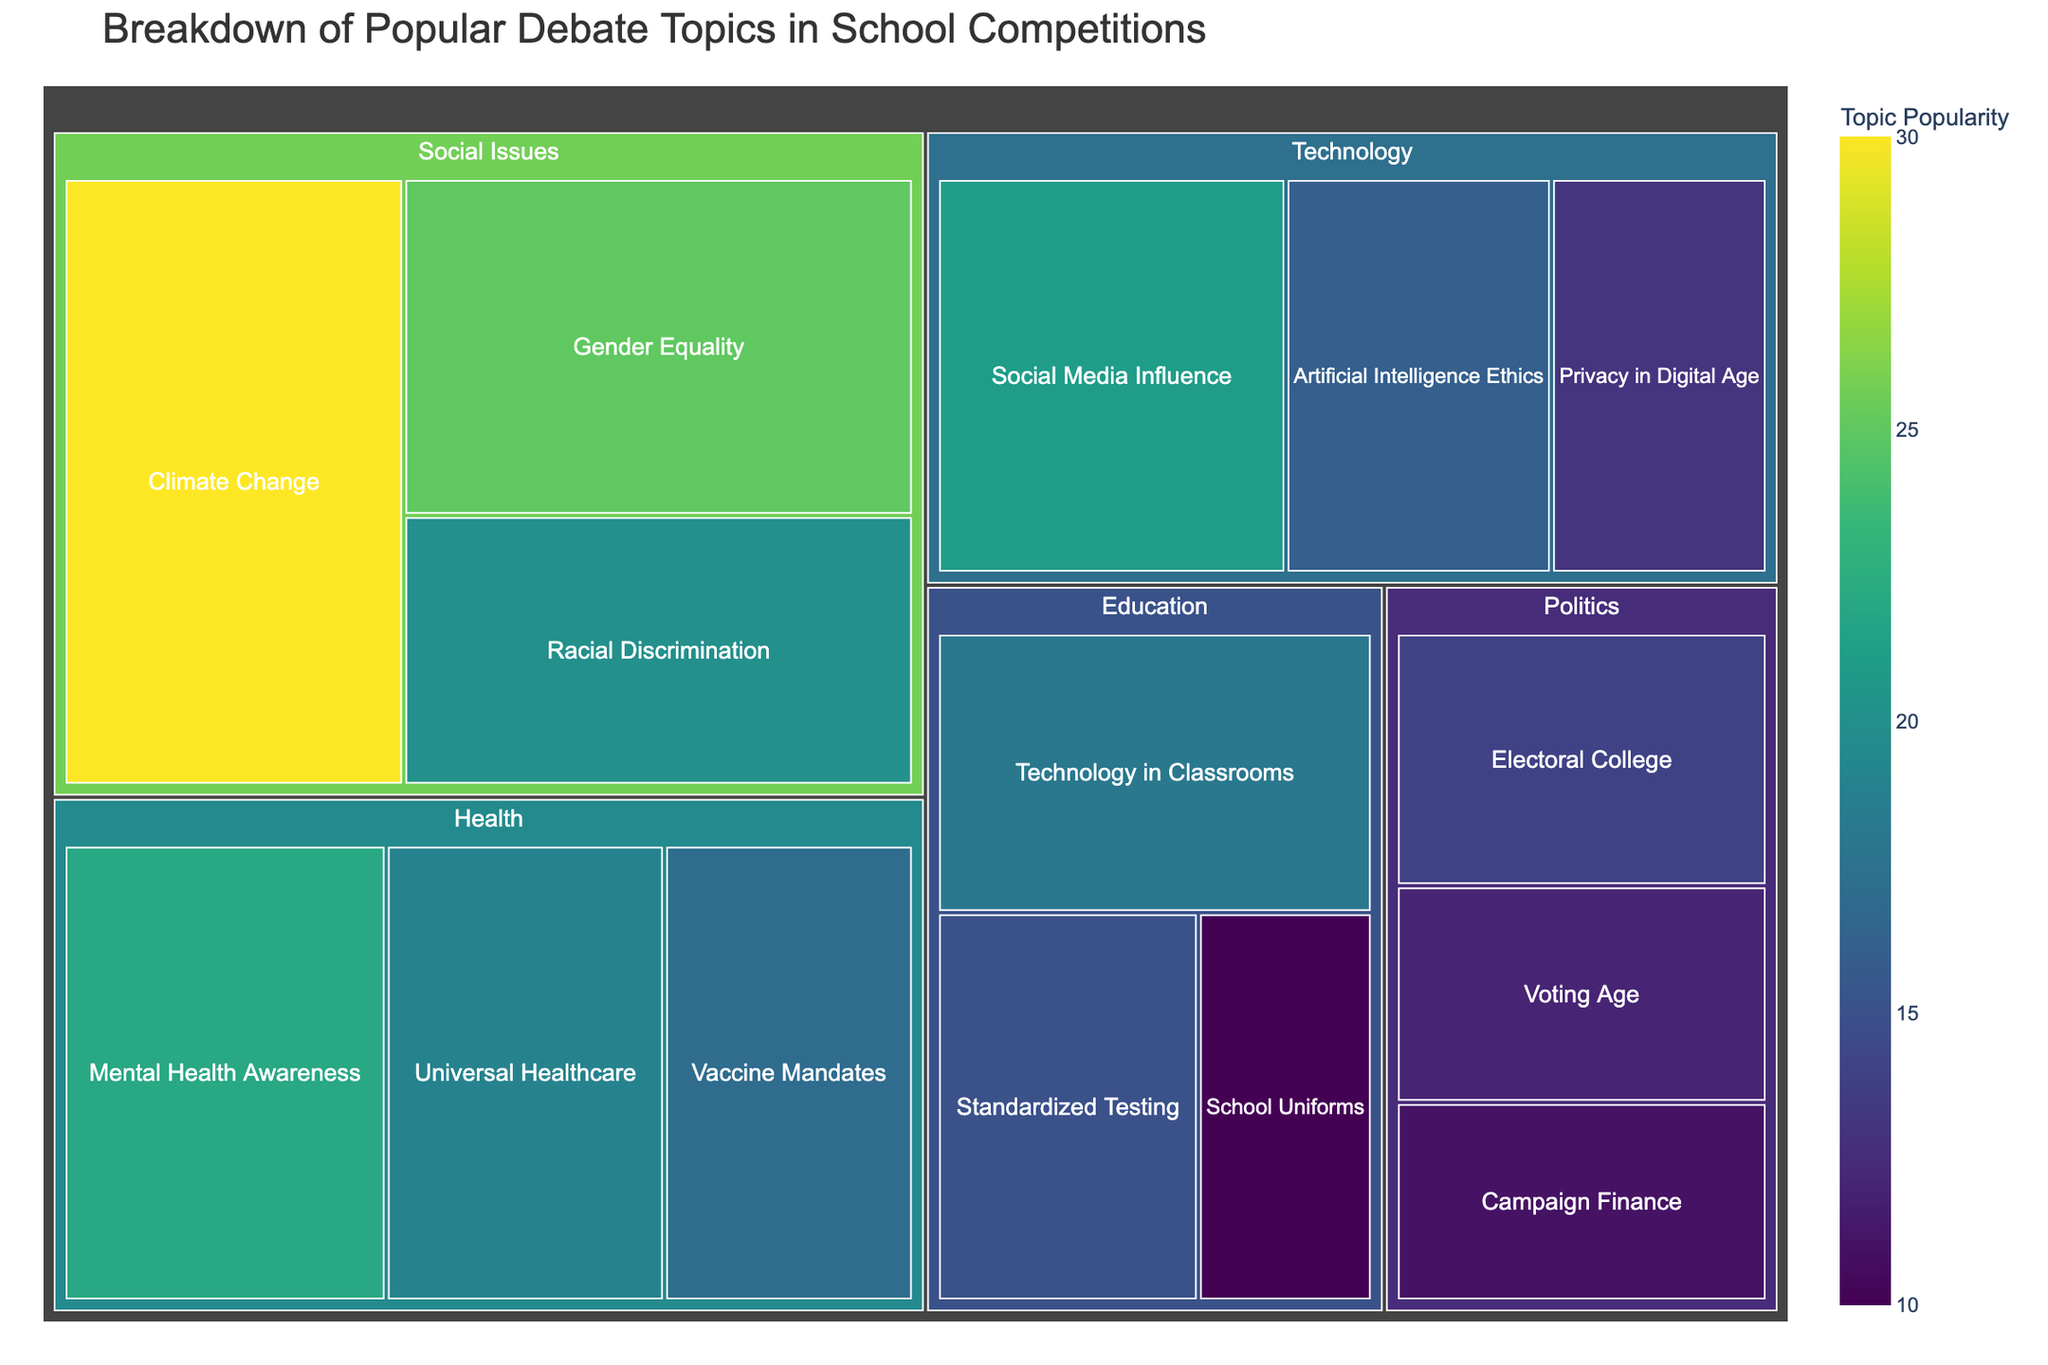What is the title of the treemap? The title can be found at the top of the figure and it is prominently displayed. The title is usually the first piece of text visible.
Answer: Breakdown of Popular Debate Topics in School Competitions Which subcategory under "Health" has the highest popularity? By examining the subcategories under "Health" and comparing their values, you can determine which one has the highest value.
Answer: Mental Health Awareness What is the total popularity of all subcategories under "Social Issues"? To find the total, sum up the values of all subcategories under "Social Issues": 25 (Gender Equality) + 30 (Climate Change) + 20 (Racial Discrimination).
Answer: 75 Which category has the lowest total popularity? Calculate the sum of the values for each category. The sums are then compared to find the category with the lowest total value:
- Social Issues: 75
- Education: 43
- Politics: 37
- Health: 58
- Technology: 50
The category with the lowest total sum is Politics.
Answer: Politics What are the two most popular subcategories overall? Identify and compare all subcategory values across the treemap to find the two highest values. Climate Change (30) and Gender Equality (25) are the top two.
Answer: Climate Change and Gender Equality How does the popularity of "Voting Age" compare to "School Uniforms"? Directly compare the values assigned to each subcategory: Voting Age (12) and School Uniforms (10).
Answer: Voting Age is more popular than School Uniforms What is the average popularity of all subcategories under "Technology"? Calculate the total value for the Technology subcategories and divide by the number of subcategories. (21 + 16 + 13) / 3.
Answer: 16.67 Which category has the most diverse range of subcategory popularity values? Look for the category where the highest subcategory value minus the lowest subcategory value is the greatest. In Social Issues (30-20=10), Education (18-10=8), Politics (14-11=3), Health (22-17=5), Technology (21-13=8).
Answer: Social Issues What is the relative size of “Universal Healthcare” compared to “Artificial Intelligence Ethics”? Compare the values directly: Universal Healthcare (19) and Artificial Intelligence Ethics (16). Calculate ratio if needed: 19/16 ≈ 1.19.
Answer: Universal Healthcare is more popular How many subcategories have a popularity value greater than 20? Identify and count all subcategories with values exceeding 20. They are Gender Equality (25), Climate Change (30), and Mental Health Awareness (22).
Answer: Three 